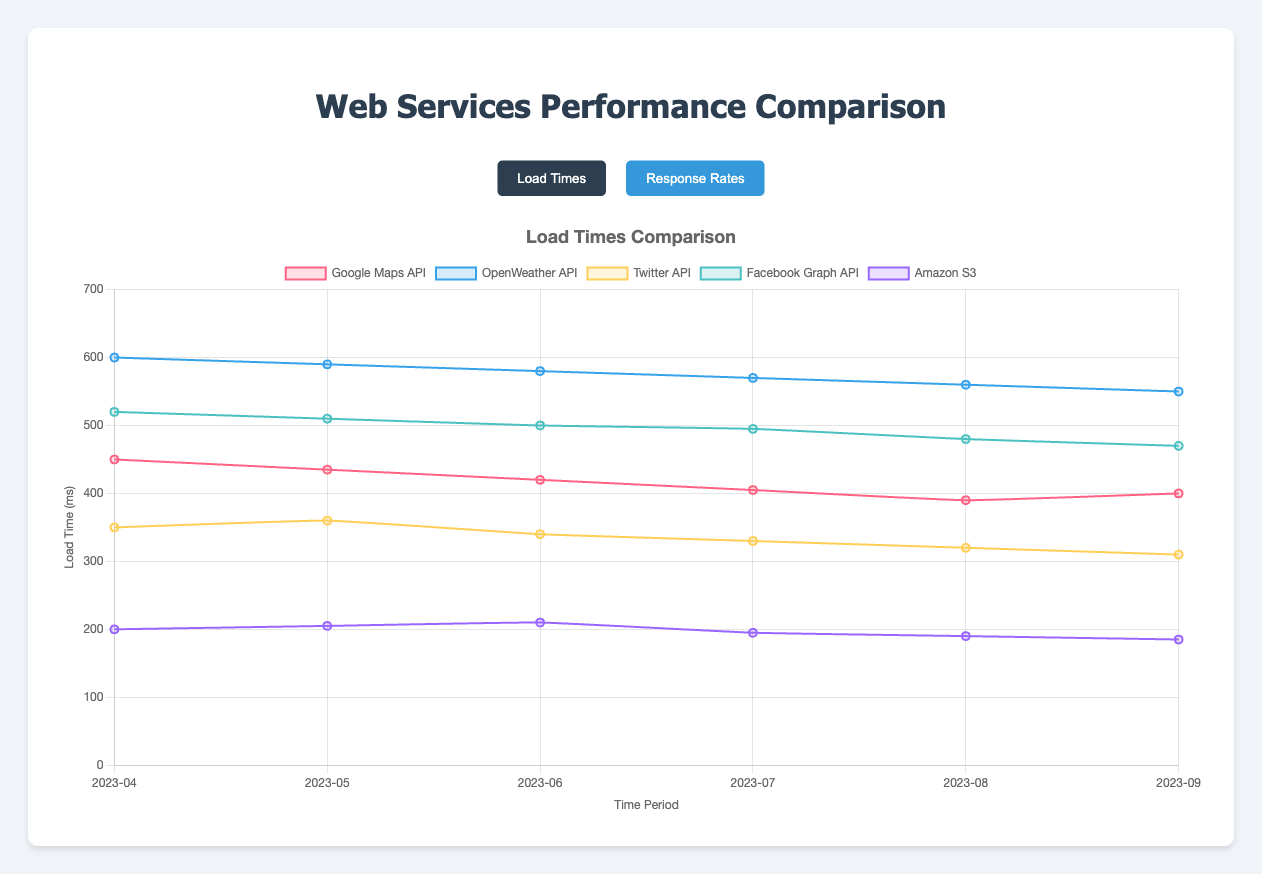Which web service has the fastest load time in September 2023? By looking at the load times in September 2023 for each web service, we see that Amazon S3, with a load time of 185 ms, is the fastest.
Answer: Amazon S3 How did Google Maps API's load time change from April to September 2023? Google's load times were 450 ms in April 2023 and 400 ms in September 2023. The change in load time is 450 - 400 = 50 ms, showing a decrease in load time.
Answer: 50 ms decrease What was the lowest response rate recorded for Facebook Graph API over the six-month period? By looking at the response rates for the Facebook Graph API, the lowest rate was 96.4% in August 2023.
Answer: 96.4% Compare the response rates of Twitter API and OpenWeather API in July 2023. Which one performed better? In July 2023, Twitter API had a response rate of 99.0%, while OpenWeather API had a response rate of 97.5%. Twitter API had a better performance.
Answer: Twitter API What is the average load time of OpenWeather API from April to September 2023? Calculate the average by summing the load times (600 + 590 + 580 + 570 + 560 + 550) and dividing by 6. The total is 3450, so the average is 3450 / 6 = 575 ms.
Answer: 575 ms Which two web services showed an increase in load time from August to September 2023? By comparing load times between August and September 2023, Google Maps API increased from 390 to 400 ms and Amazon S3 increased from 190 to 185 ms. Therefore, Google Maps API and Amazon S3 had an increase.
Answer: Google Maps API and Amazon S3 Which web service had the highest improvement in response rate from April to September 2023? Calculate the difference in response rates from April to September for each service. The highest increase is for Amazon S3, which improved from 99.7% to 99.8%.
Answer: Amazon S3 What is the overall trend in load times for Twitter API from April to September 2023? By observing the load times for Twitter API: 350, 360, 340, 330, 320, 310 ms, we notice an overall decreasing trend over the six months.
Answer: Decreasing trend How much did the response rate for Google Maps API improve from May to June 2023? The response rate in May 2023 was 98.2%, and in June 2023 it was 98.6%. The improvement is 98.6 - 98.2 = 0.4%.
Answer: 0.4% Which month had the smallest difference in response rate between all web services? To find the smallest difference, look at the spread between the highest and lowest response rates for each month. In September 2023, the highest rate is 99.9% (Amazon S3) and the lowest is 96.6% (Facebook Graph API), so the difference is 3.3%. This is the smallest difference when compared to other months.
Answer: September 2023 